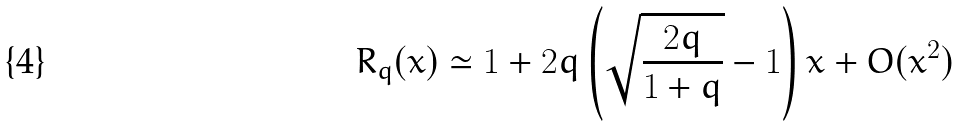<formula> <loc_0><loc_0><loc_500><loc_500>R _ { q } ( x ) \simeq 1 + 2 q \left ( \sqrt { \frac { 2 q } { 1 + q } } - 1 \right ) x + O ( x ^ { 2 } )</formula> 